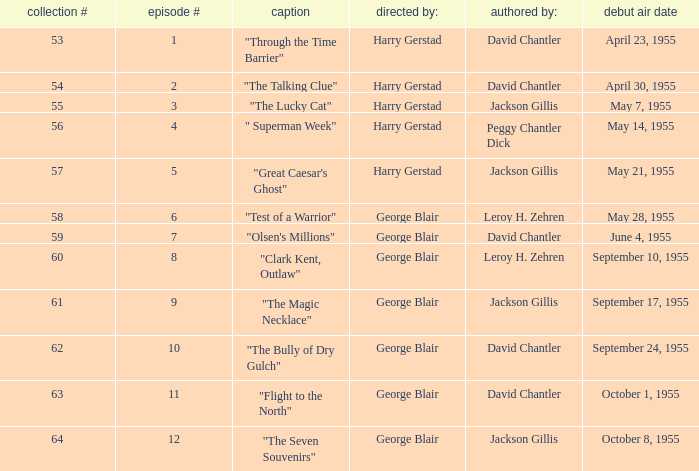When did season 9 originally air? September 17, 1955. 